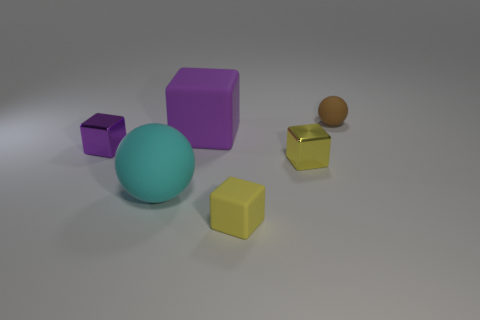Subtract all small purple metal cubes. How many cubes are left? 3 Subtract all brown cylinders. How many purple cubes are left? 2 Subtract 2 cubes. How many cubes are left? 2 Add 3 small green matte blocks. How many objects exist? 9 Subtract all green blocks. Subtract all green balls. How many blocks are left? 4 Subtract all blocks. How many objects are left? 2 Subtract all purple objects. Subtract all small brown rubber things. How many objects are left? 3 Add 4 tiny purple metallic things. How many tiny purple metallic things are left? 5 Add 1 tiny yellow cubes. How many tiny yellow cubes exist? 3 Subtract 0 blue cylinders. How many objects are left? 6 